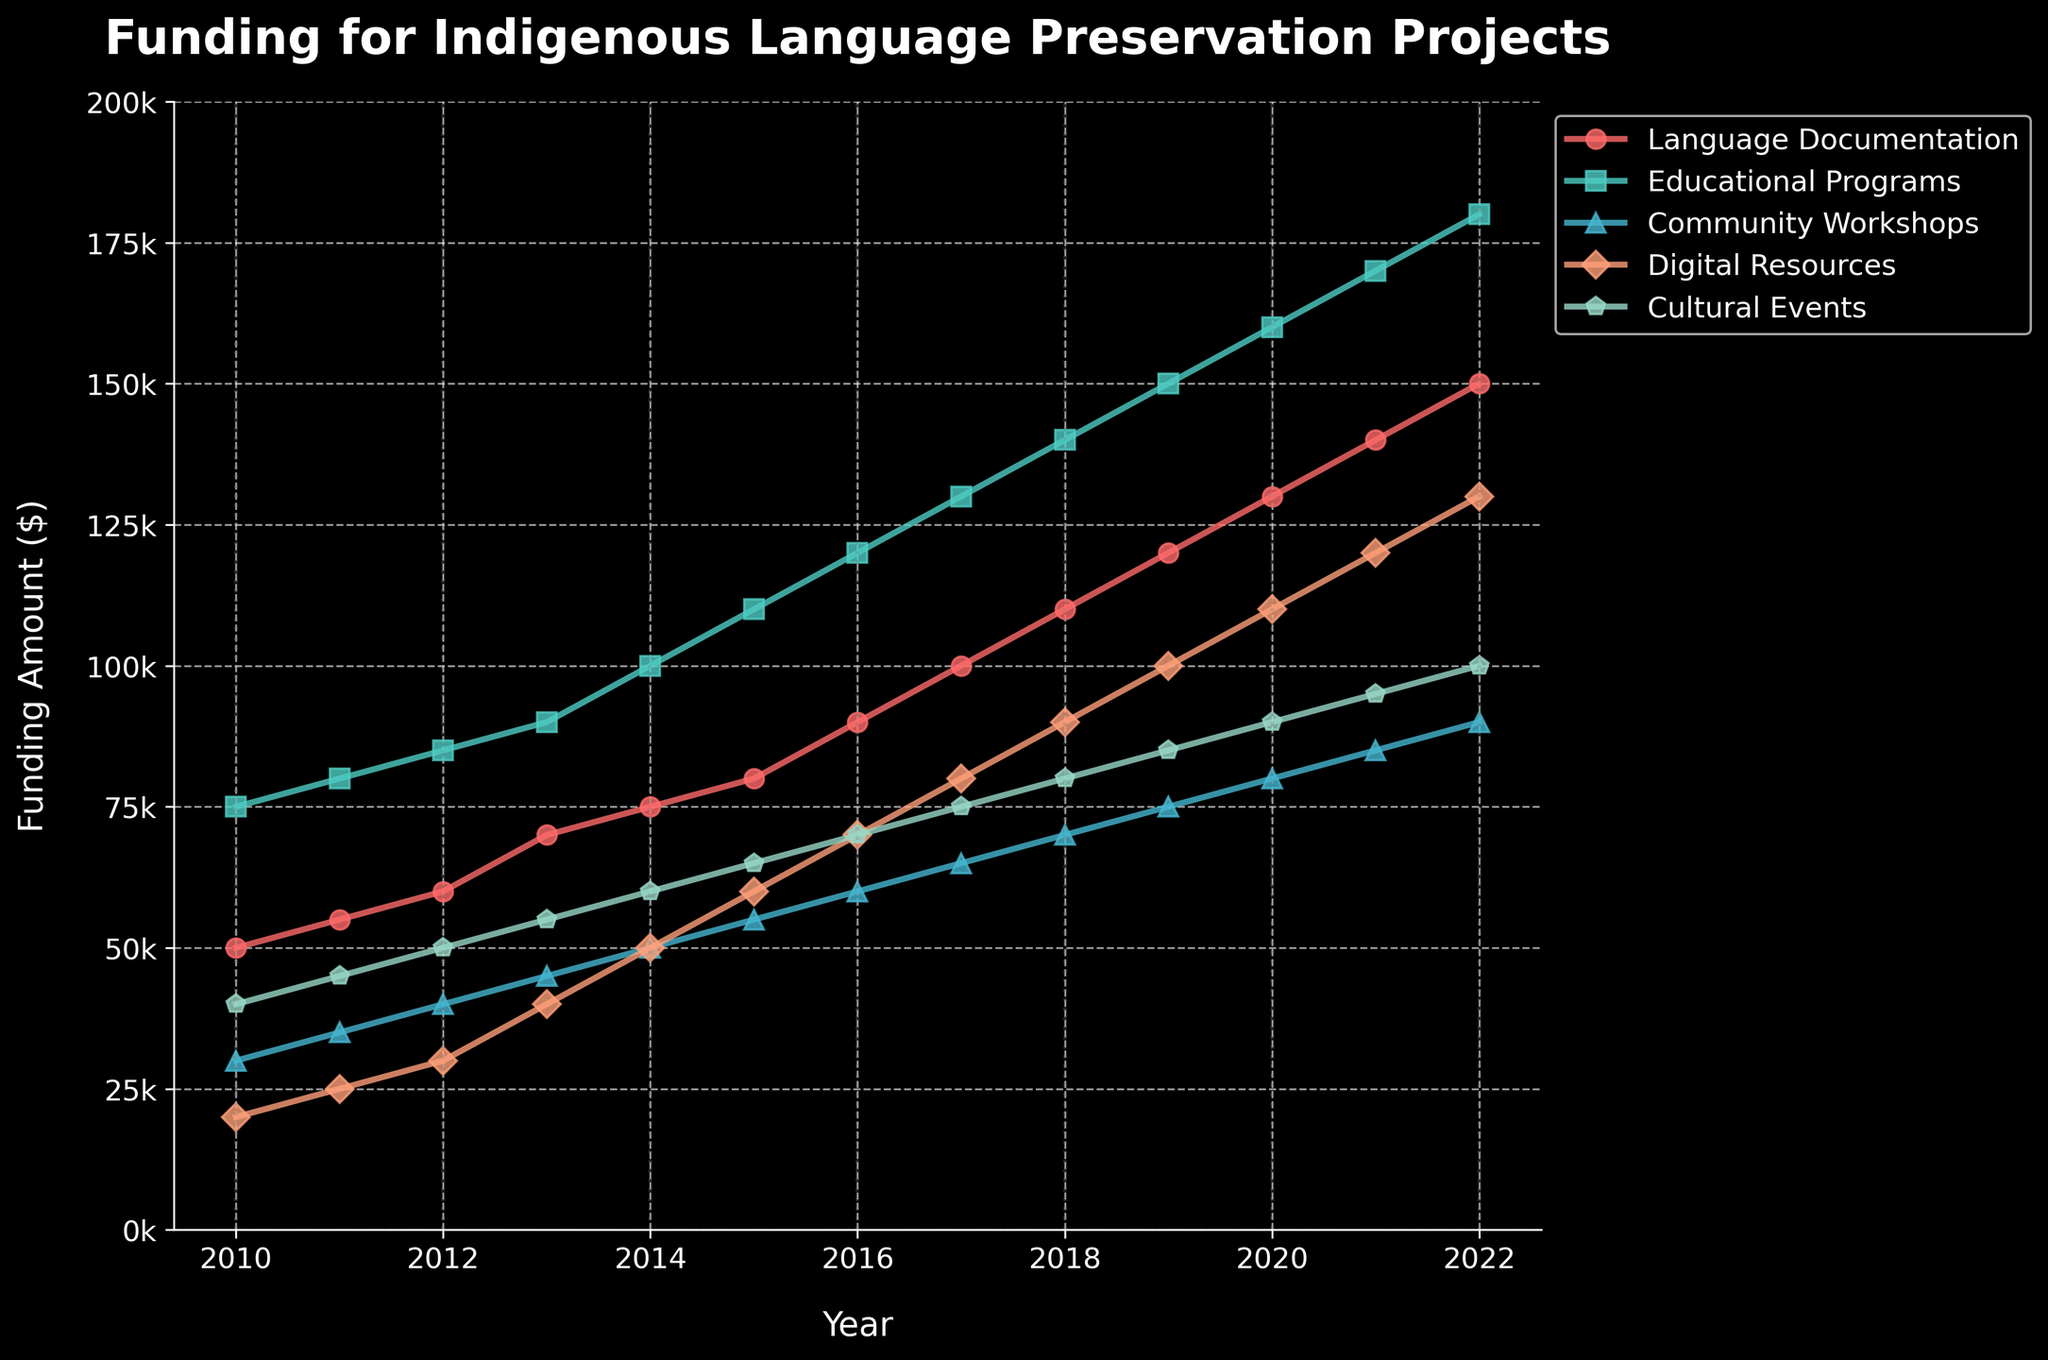Which initiative saw the highest funding in 2022? Look at the endpoint of the lines for 2022. The 'Educational Programs' line is the highest.
Answer: Educational Programs How much did the funding for Language Documentation and Digital Resources increase from 2010 to 2022? Subtract the 2010 funding from the 2022 funding for both initiatives. For Language Documentation, it's 150,000 - 50,000 = 100,000. For Digital Resources, it's 130,000 - 20,000 = 110,000.
Answer: 100,000 and 110,000 Which initiative had the smallest increase in funding between 2015 and 2020? Calculate the difference in funding for each initiative between 2015 and 2020. Language Documentation: 130,000 - 80,000 = 50,000, Educational Programs: 160,000 - 110,000 = 50,000, Community Workshops: 80,000 - 55,000 = 25,000, Digital Resources: 110,000 - 60,000 = 50,000, Cultural Events: 90,000 - 65,000 = 25,000. Community Workshops and Cultural Events had the smallest increase.
Answer: Community Workshops and Cultural Events By how much did the funding for Community Workshops differ from Cultural Events in 2019? Check the values for both initiatives in 2019. Community Workshops: 75,000, Cultural Events: 85,000. The difference is 85,000 - 75,000 = 10,000.
Answer: 10,000 What is the proportional increase in funding for Educational Programs from 2010 to 2022? Determine the increase and the original value, then calculate the proportion. The increase is 180,000 - 75,000 = 105,000. Proportionally, that's 105,000 / 75,000 = 1.4, or 140%.
Answer: 140% On average, how much annual funding was allocated to Cultural Events from 2010 to 2022? Sum all yearly funding amounts for Cultural Events and divide by the number of years (13). The sum is 40,000 + 45,000 + 50,000 + 55,000 + 60,000 + 65,000 + 70,000 + 75,000 + 80,000 + 85,000 + 90,000 + 95,000 + 100,000 = 910,000. Average is 910,000 / 13 ≈ 70,000.
Answer: ~70,000 